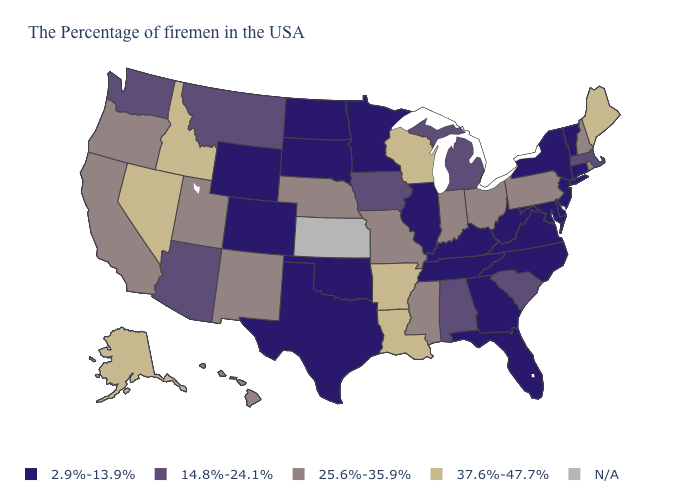Name the states that have a value in the range 25.6%-35.9%?
Give a very brief answer. Rhode Island, New Hampshire, Pennsylvania, Ohio, Indiana, Mississippi, Missouri, Nebraska, New Mexico, Utah, California, Oregon, Hawaii. What is the value of New Hampshire?
Answer briefly. 25.6%-35.9%. Does the map have missing data?
Keep it brief. Yes. What is the value of Oregon?
Quick response, please. 25.6%-35.9%. Among the states that border Maryland , which have the highest value?
Be succinct. Pennsylvania. Name the states that have a value in the range 25.6%-35.9%?
Give a very brief answer. Rhode Island, New Hampshire, Pennsylvania, Ohio, Indiana, Mississippi, Missouri, Nebraska, New Mexico, Utah, California, Oregon, Hawaii. Does Iowa have the lowest value in the USA?
Give a very brief answer. No. What is the value of California?
Short answer required. 25.6%-35.9%. What is the value of Connecticut?
Answer briefly. 2.9%-13.9%. Name the states that have a value in the range 25.6%-35.9%?
Be succinct. Rhode Island, New Hampshire, Pennsylvania, Ohio, Indiana, Mississippi, Missouri, Nebraska, New Mexico, Utah, California, Oregon, Hawaii. What is the value of Rhode Island?
Answer briefly. 25.6%-35.9%. Which states have the lowest value in the USA?
Keep it brief. Vermont, Connecticut, New York, New Jersey, Delaware, Maryland, Virginia, North Carolina, West Virginia, Florida, Georgia, Kentucky, Tennessee, Illinois, Minnesota, Oklahoma, Texas, South Dakota, North Dakota, Wyoming, Colorado. How many symbols are there in the legend?
Keep it brief. 5. Does Connecticut have the lowest value in the Northeast?
Short answer required. Yes. 